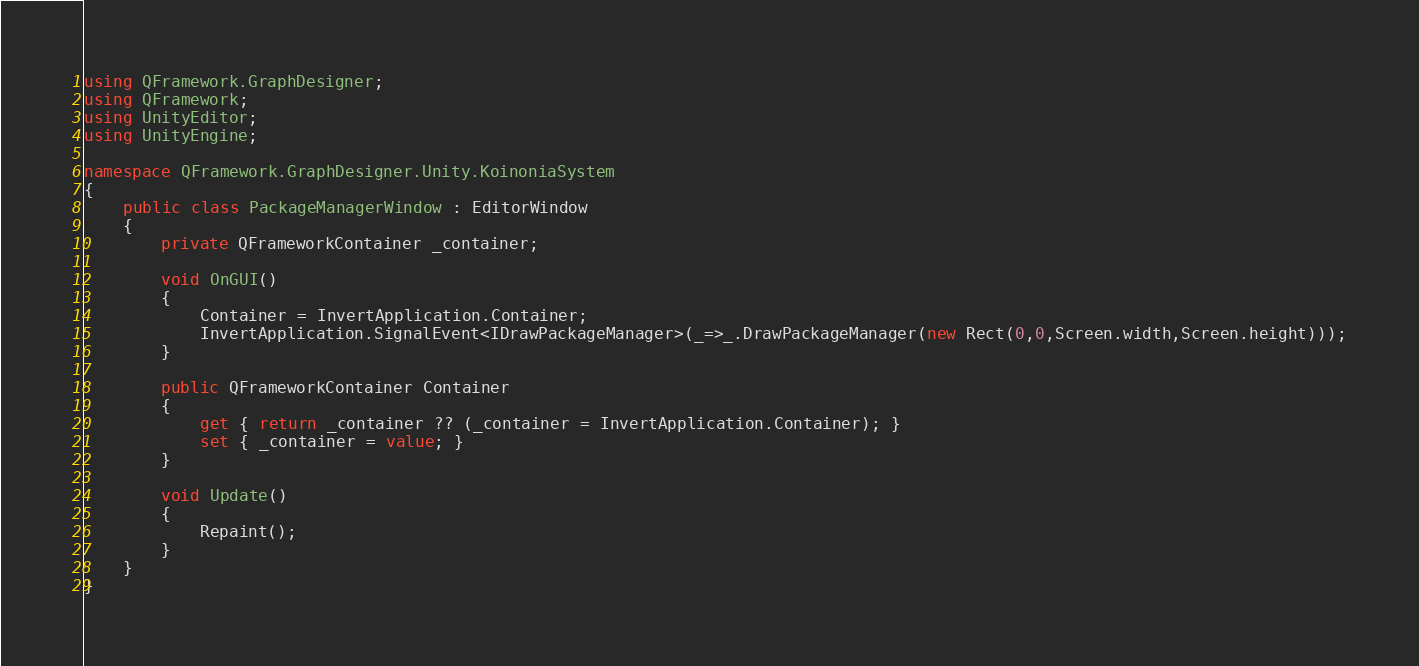<code> <loc_0><loc_0><loc_500><loc_500><_C#_>using QFramework.GraphDesigner;
using QFramework;
using UnityEditor;
using UnityEngine;

namespace QFramework.GraphDesigner.Unity.KoinoniaSystem
{
    public class PackageManagerWindow : EditorWindow
    {
        private QFrameworkContainer _container;

        void OnGUI()
        {
            Container = InvertApplication.Container;
            InvertApplication.SignalEvent<IDrawPackageManager>(_=>_.DrawPackageManager(new Rect(0,0,Screen.width,Screen.height)));
        }

        public QFrameworkContainer Container
        {
            get { return _container ?? (_container = InvertApplication.Container); }
            set { _container = value; }
        }

        void Update()
        {
            Repaint();
        }
    }
}</code> 